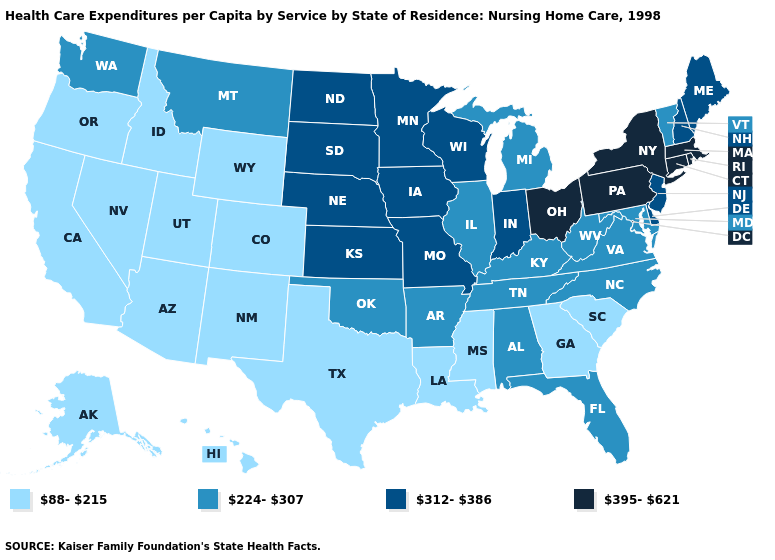What is the value of Nevada?
Concise answer only. 88-215. Which states hav the highest value in the MidWest?
Write a very short answer. Ohio. Does Wyoming have the same value as Utah?
Answer briefly. Yes. Does Florida have the same value as South Carolina?
Answer briefly. No. Does Nevada have the highest value in the USA?
Quick response, please. No. Does Vermont have the lowest value in the Northeast?
Quick response, please. Yes. What is the value of Ohio?
Answer briefly. 395-621. What is the value of Mississippi?
Quick response, please. 88-215. Name the states that have a value in the range 224-307?
Short answer required. Alabama, Arkansas, Florida, Illinois, Kentucky, Maryland, Michigan, Montana, North Carolina, Oklahoma, Tennessee, Vermont, Virginia, Washington, West Virginia. Which states have the lowest value in the USA?
Quick response, please. Alaska, Arizona, California, Colorado, Georgia, Hawaii, Idaho, Louisiana, Mississippi, Nevada, New Mexico, Oregon, South Carolina, Texas, Utah, Wyoming. What is the value of New Hampshire?
Be succinct. 312-386. Which states hav the highest value in the West?
Concise answer only. Montana, Washington. Name the states that have a value in the range 312-386?
Give a very brief answer. Delaware, Indiana, Iowa, Kansas, Maine, Minnesota, Missouri, Nebraska, New Hampshire, New Jersey, North Dakota, South Dakota, Wisconsin. Does Oklahoma have the lowest value in the South?
Answer briefly. No. Does Nebraska have the highest value in the USA?
Keep it brief. No. 